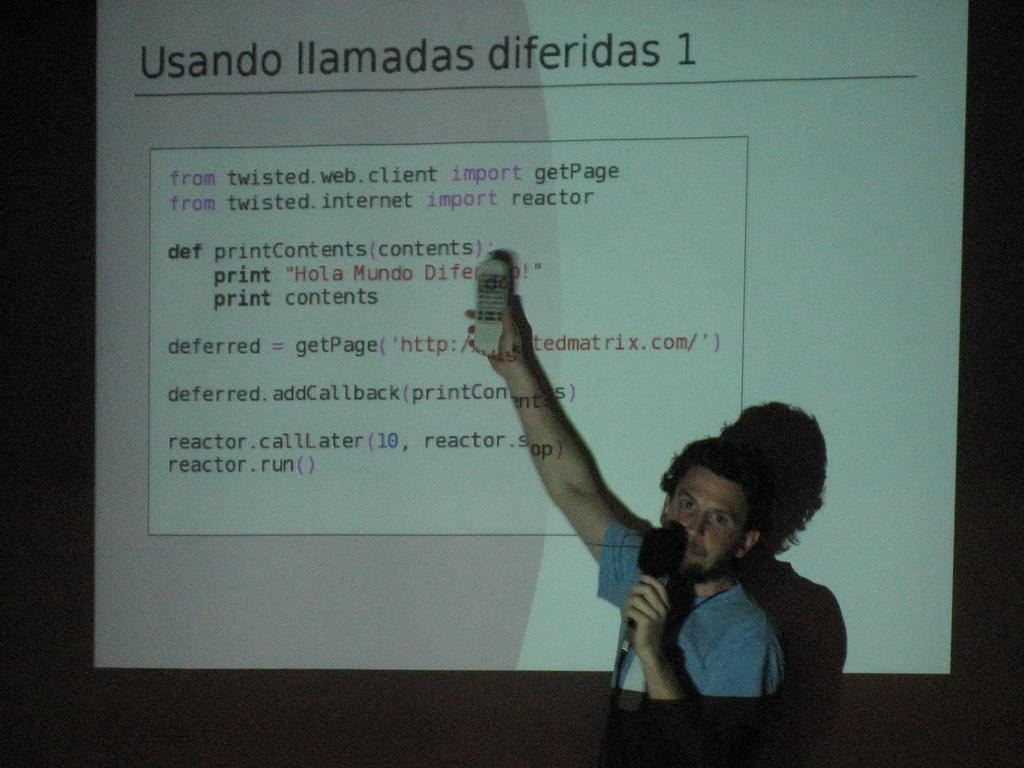What is the main subject of the image? There is a man in the image. What is the man doing in the image? The man is standing and holding a mic in one hand and a remote in the other hand. What can be seen in the background of the image? There is a display screen in the background of the image. What is visible on the display screen? There is text visible on the display screen. What type of plants can be seen growing on the man's head in the image? There are no plants visible on the man's head in the image. Can you describe the feather that is attached to the remote in the image? There is no feather attached to the remote in the image. 